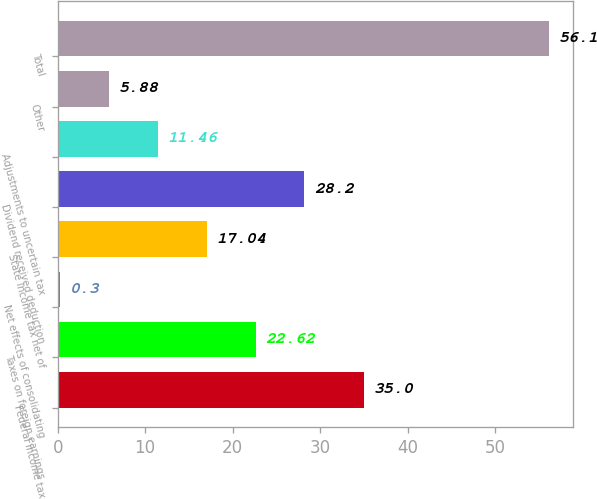<chart> <loc_0><loc_0><loc_500><loc_500><bar_chart><fcel>Federal income tax<fcel>Taxes on foreign earnings<fcel>Net effects of consolidating<fcel>State income tax net of<fcel>Dividend received deduction<fcel>Adjustments to uncertain tax<fcel>Other<fcel>Total<nl><fcel>35<fcel>22.62<fcel>0.3<fcel>17.04<fcel>28.2<fcel>11.46<fcel>5.88<fcel>56.1<nl></chart> 